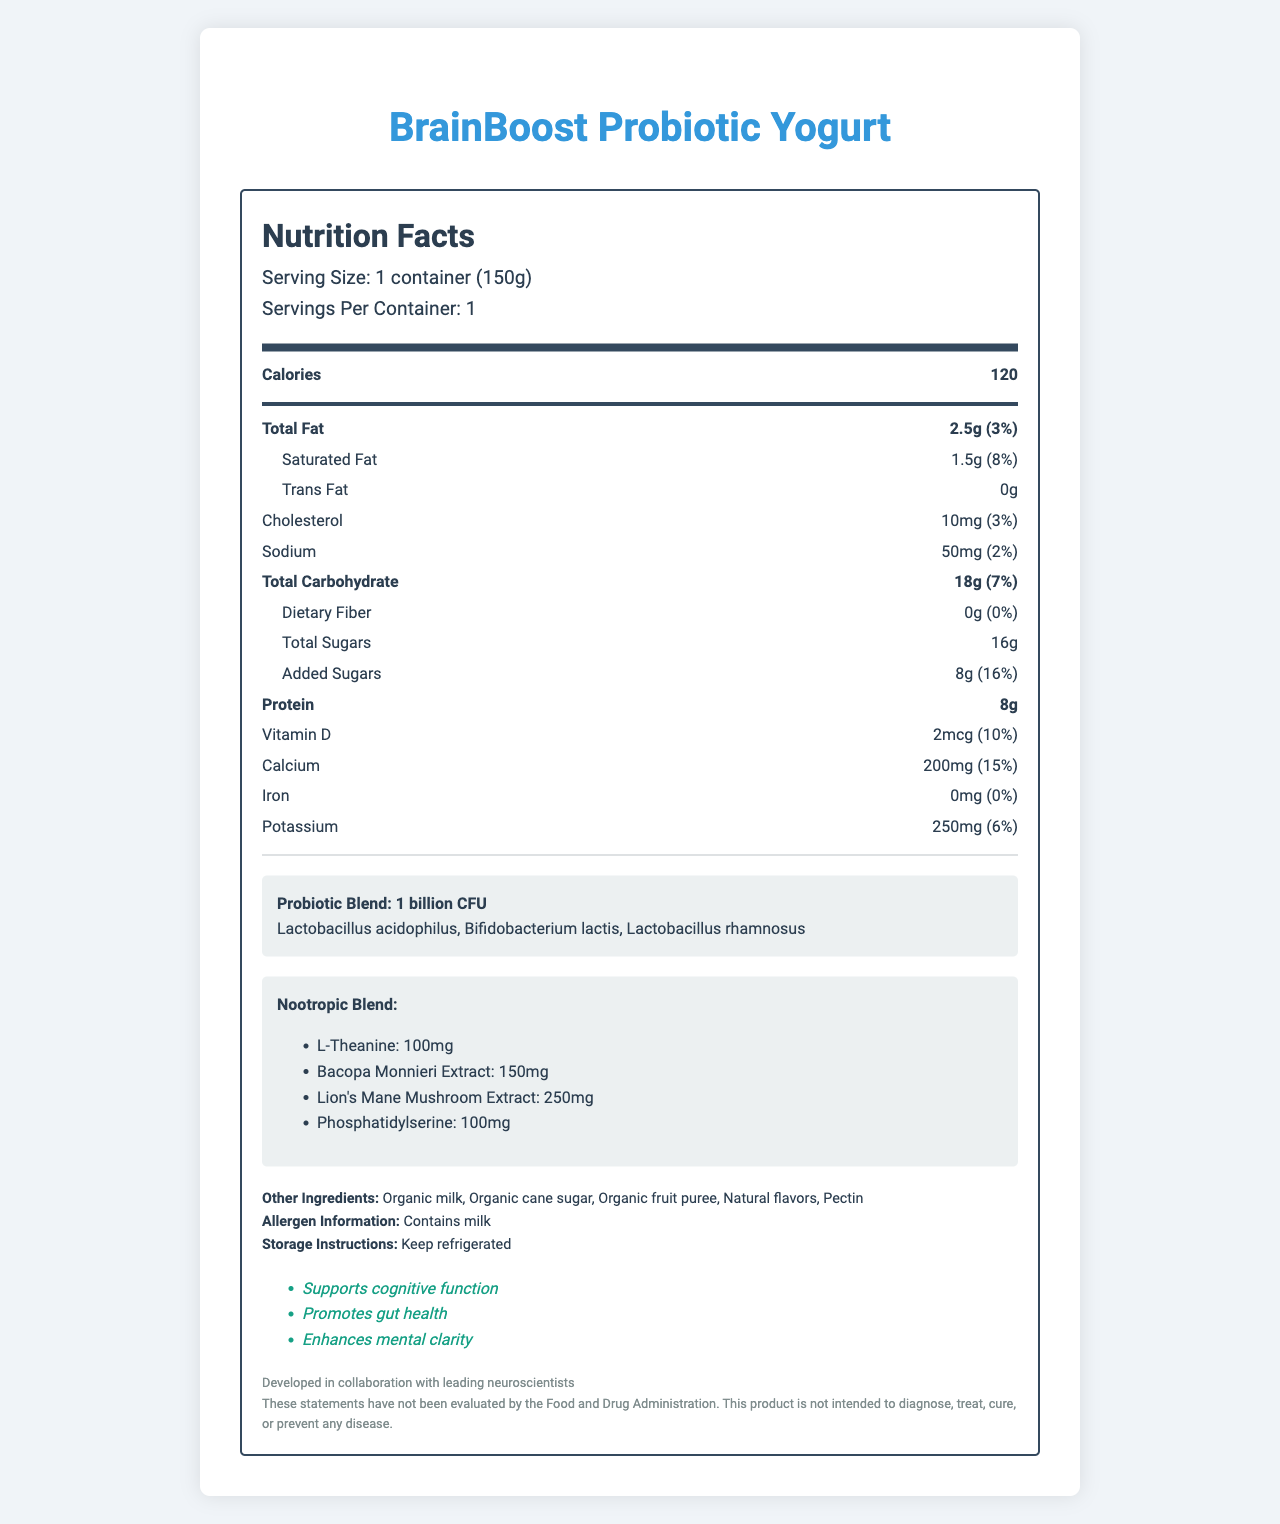what is the serving size for BrainBoost Probiotic Yogurt? The serving size is listed at the top of the Nutrition Facts label as "Serving Size: 1 container (150g)".
Answer: 1 container (150g) how many calories are in one serving of BrainBoost Probiotic Yogurt? The document shows "Calories: 120" in a prominent, bold section under "Nutrition Facts".
Answer: 120 what percentage of daily value for calcium does one serving provide? Under the nutrient section, it states "Calcium: 200mg (15%)".
Answer: 15% list the probiotic strains present in BrainBoost Probiotic Yogurt. The strains are listed under the section "Probiotic Blend: 1 billion CFU".
Answer: Lactobacillus acidophilus, Bifidobacterium lactis, Lactobacillus rhamnosus how much protein is in a serving? The protein content is listed under the main nutrient section as "Protein: 8g".
Answer: 8g what are the health claims made on the product? The health claims are listed in the document under "Health Claims".
Answer: Supports cognitive function, Promotes gut health, Enhances mental clarity what are the ingredients in the nootropic blend? The nootropic blend ingredients are clearly listed in a dedicated section.
Answer: L-Theanine, Bacopa Monnieri Extract, Lion's Mane Mushroom Extract, Phosphatidylserine how many added sugars are in one serving? The document lists "Added Sugars: 8g (16%)".
Answer: 8g does the product contain any dietary fiber? Under the carbohydrate section, it states "Dietary Fiber: 0g (0%)".
Answer: No what are the storage instructions for BrainBoost Probiotic Yogurt? The storage instructions are annotated clearly in the additional information section.
Answer: Keep refrigerated How much sodium does one serving contain? A. 30mg B. 50mg C. 75mg D. 100mg Under the nutrient section, it states "Sodium: 50mg (2%)".
Answer: B. 50mg Which of the following is not listed as an ingredient? A. Natural flavors B. Pectin C. Organic honey D. Organic cane sugar The document lists other ingredients as: "Organic milk, Organic cane sugar, Organic fruit puree, Natural flavors, Pectin". Organic honey is not listed.
Answer: C. Organic honey Is the product safe for someone with a milk allergy? The allergen information clearly states "Contains milk".
Answer: No Summarize the main features of BrainBoost Probiotic Yogurt mentioned in the document. The document provides comprehensive nutritional information, probiotic and nootropic ingredients, health claims, allergen information, and storage instructions for BrainBoost Probiotic Yogurt.
Answer: BrainBoost Probiotic Yogurt is a 150g serving probiotic-rich yogurt with added nootropic ingredients that contains 120 calories, 8g of protein, and various vitamins and minerals. It claims to support cognitive function, promote gut health, and enhance mental clarity. The product includes a blend of probiotic strains and nootropic ingredients such as L-Theanine and Bacopa Monnieri Extract. Storage instructions advise keeping it refrigerated, and it contains milk as an allergen. Are the health claims made by the manufacturer FDA approved? The disclaimer clearly states, "These statements have not been evaluated by the Food and Drug Administration."
Answer: No How much Vitamin C is in BrainBoost Probiotic Yogurt? The document does not provide information regarding the Vitamin C content in the yogurt.
Answer: Not enough information 